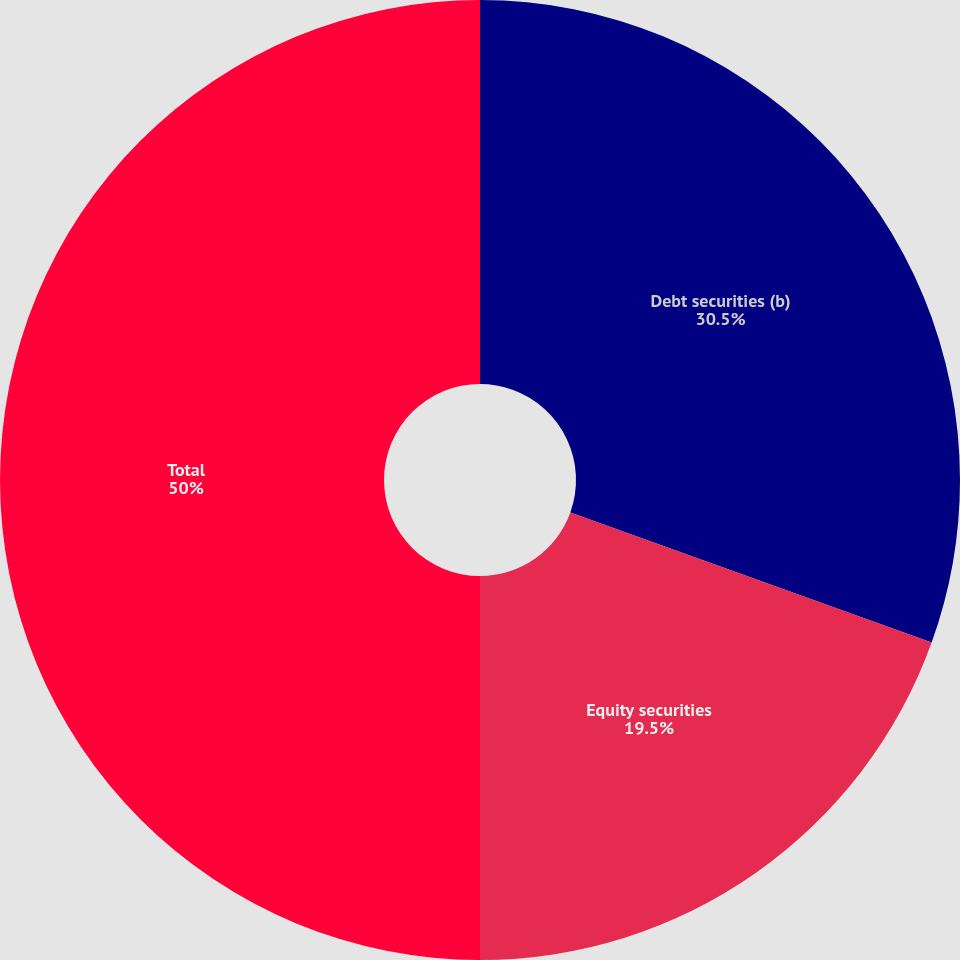Convert chart. <chart><loc_0><loc_0><loc_500><loc_500><pie_chart><fcel>Debt securities (b)<fcel>Equity securities<fcel>Total<nl><fcel>30.5%<fcel>19.5%<fcel>50.0%<nl></chart> 